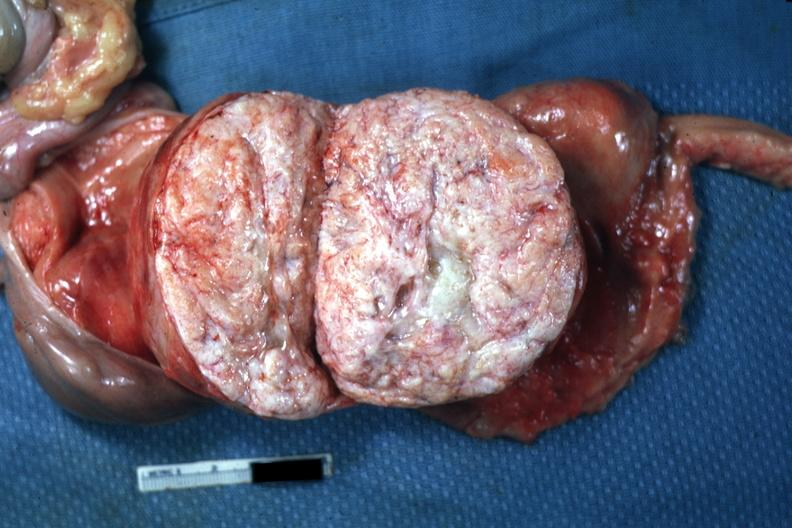how is myoma lesion quite close-up photo?
Answer the question using a single word or phrase. Typical 